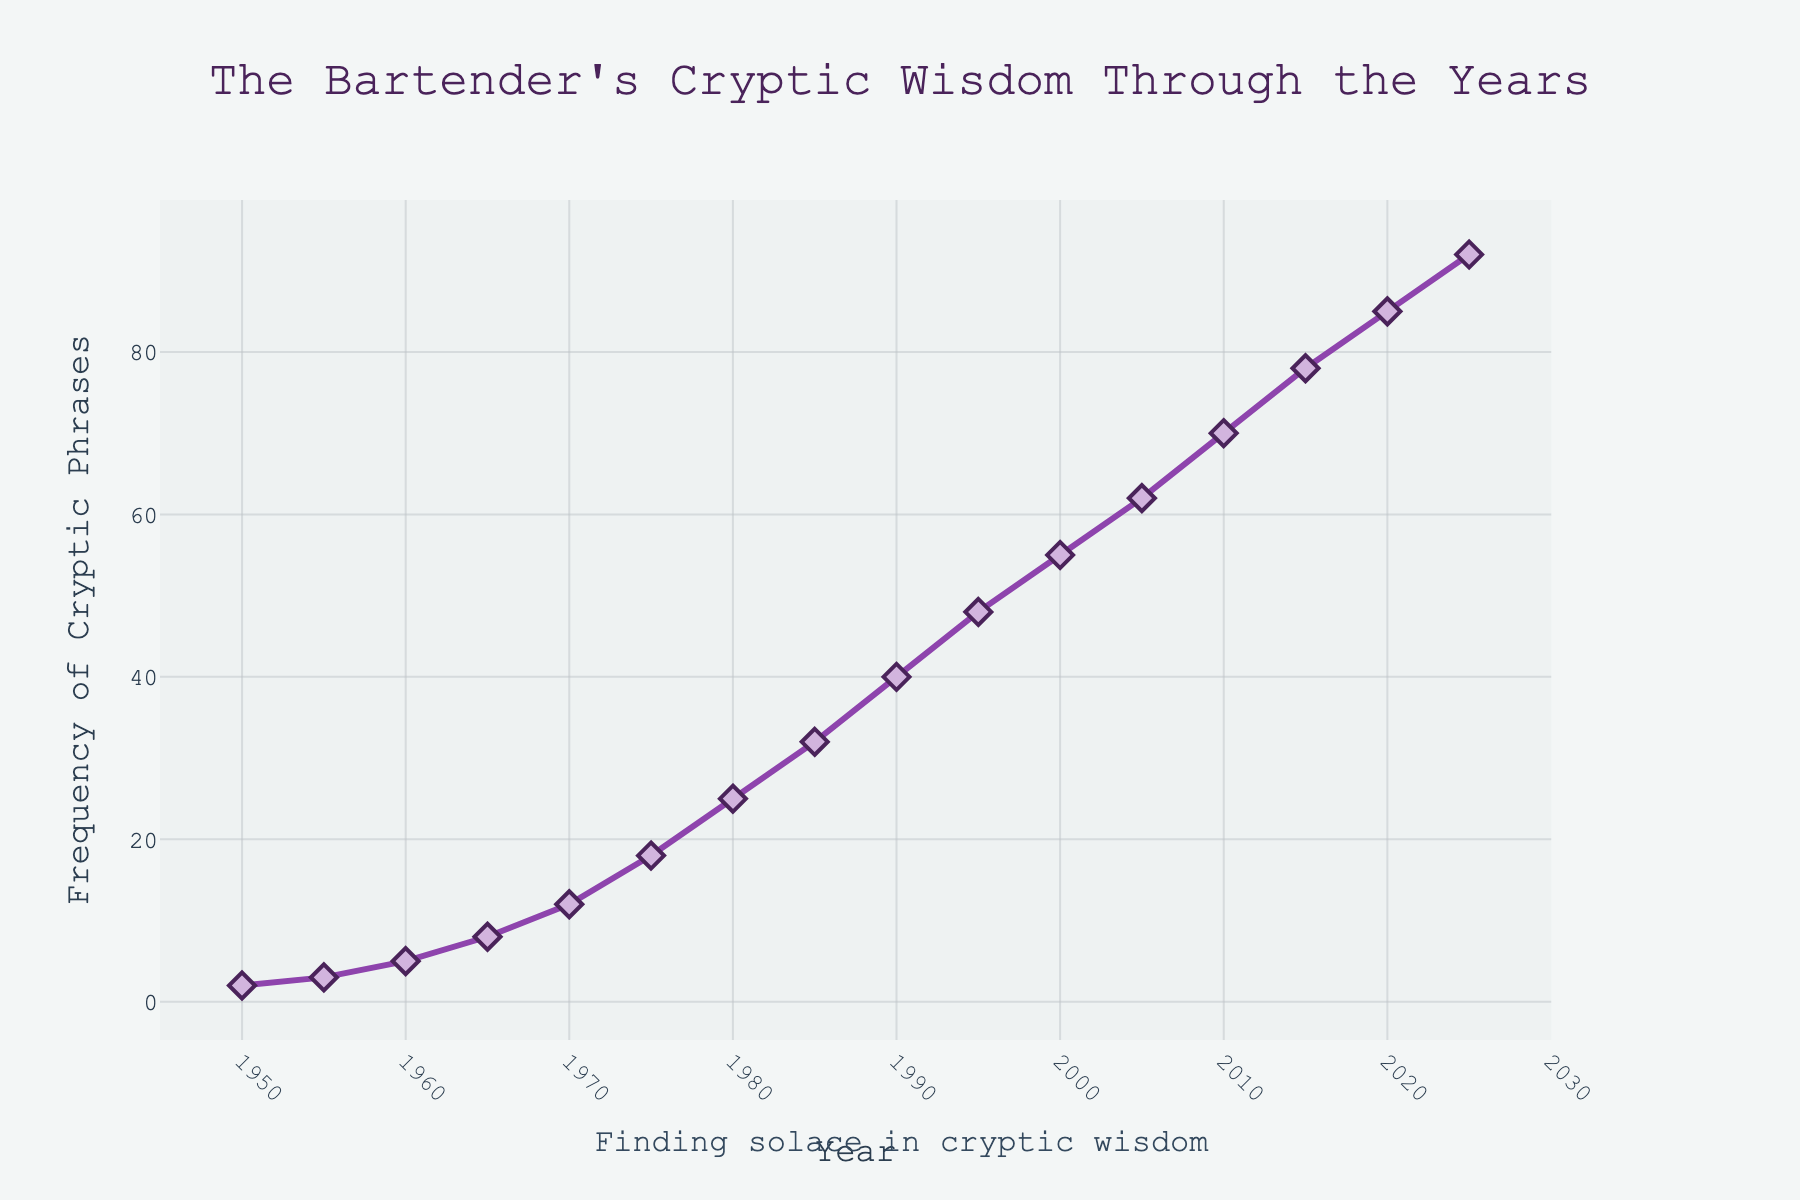What is the frequency of cryptic phrases used by bartenders in 1970? To find the frequency for the year 1970, look directly at the corresponding data point on the graph.
Answer: 12 How many years does it take for the frequency to increase from 25 to 50? Identify the years corresponding to the frequencies 25 and 48. The frequency is 25 in 1980 and approximately 50 in 1995. Subtract the earlier year from the later year.
Answer: 15 years By how much did the frequency increase from 1950 to 2025? Locate the frequency values for the years 1950 and 2025. The frequency in 1950 is 2, and in 2025 it is 92. Subtract the earlier frequency from the later frequency.
Answer: 90 Between which consecutive years did the frequency increase the most? Examine the differences in frequency between consecutive years and determine the greatest increase. The largest increase is between 1975 (18) and 1980 (25). The difference is 7.
Answer: 1975 and 1980 What is the average frequency from 2000 to 2020? Add the frequencies for 2000, 2005, 2010, 2015, and 2020. Then, divide the sum by the number of years (5). (55 + 62 + 70 + 78 + 85) / 5.
Answer: 70 Which decade experienced the highest increase in the frequency of cryptic phrases? Calculate the frequency increase for each decade by subtracting the frequency at the start of the decade from that at the end. The highest increase is from 2000 to 2010 (70 - 55 = 15).
Answer: The 2000s What trend do you observe in the frequency of cryptic phrases from 1950 to the present? Look at the overall shape of the line on the line chart, which shows a steady increase over the years from 1950 to 2020 and beyond.
Answer: Steady increase How does the frequency in 1985 compare to 2015? Identify the frequencies for 1985 and 2015, then compare them. 32 in 1985 and 78 in 2015; 2015 is much higher.
Answer: 2015 is higher 